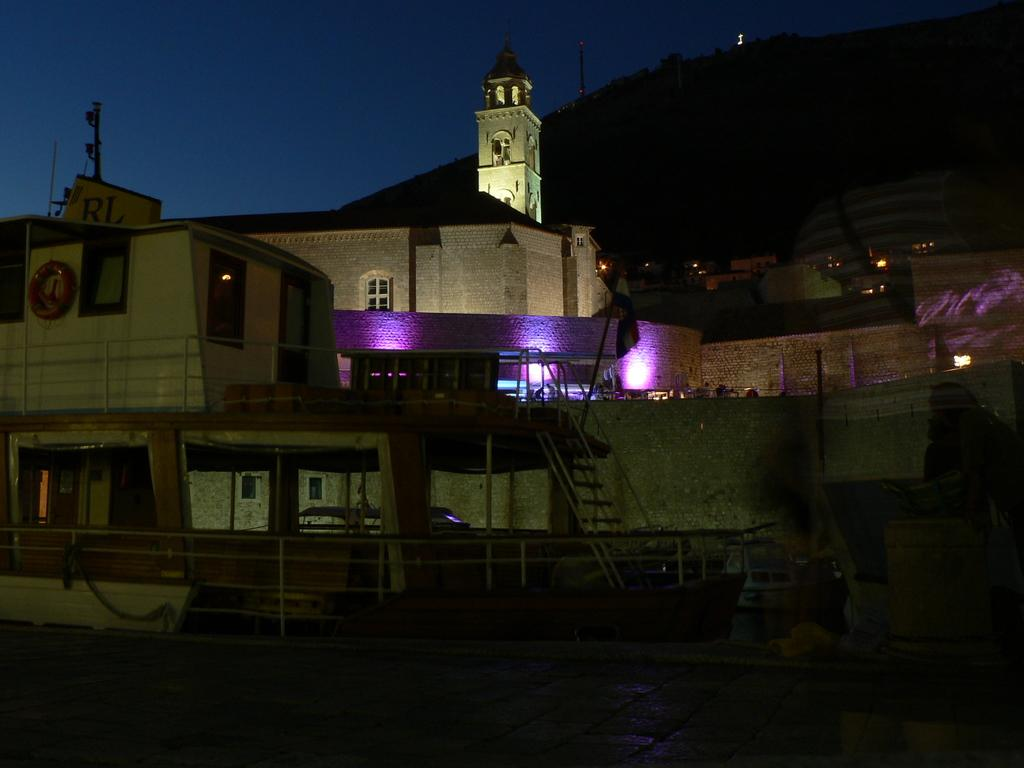What is the main subject of the image? The main subject of the image is ships. Where are the ships located? The ships are on the water. What can be seen in the background of the image? There are buildings, mountains, and the sky visible in the background of the image. What type of page is being advertised in the image? There is no page or advertisement present in the image; it features ships on the water with a background of buildings, mountains, and the sky. 